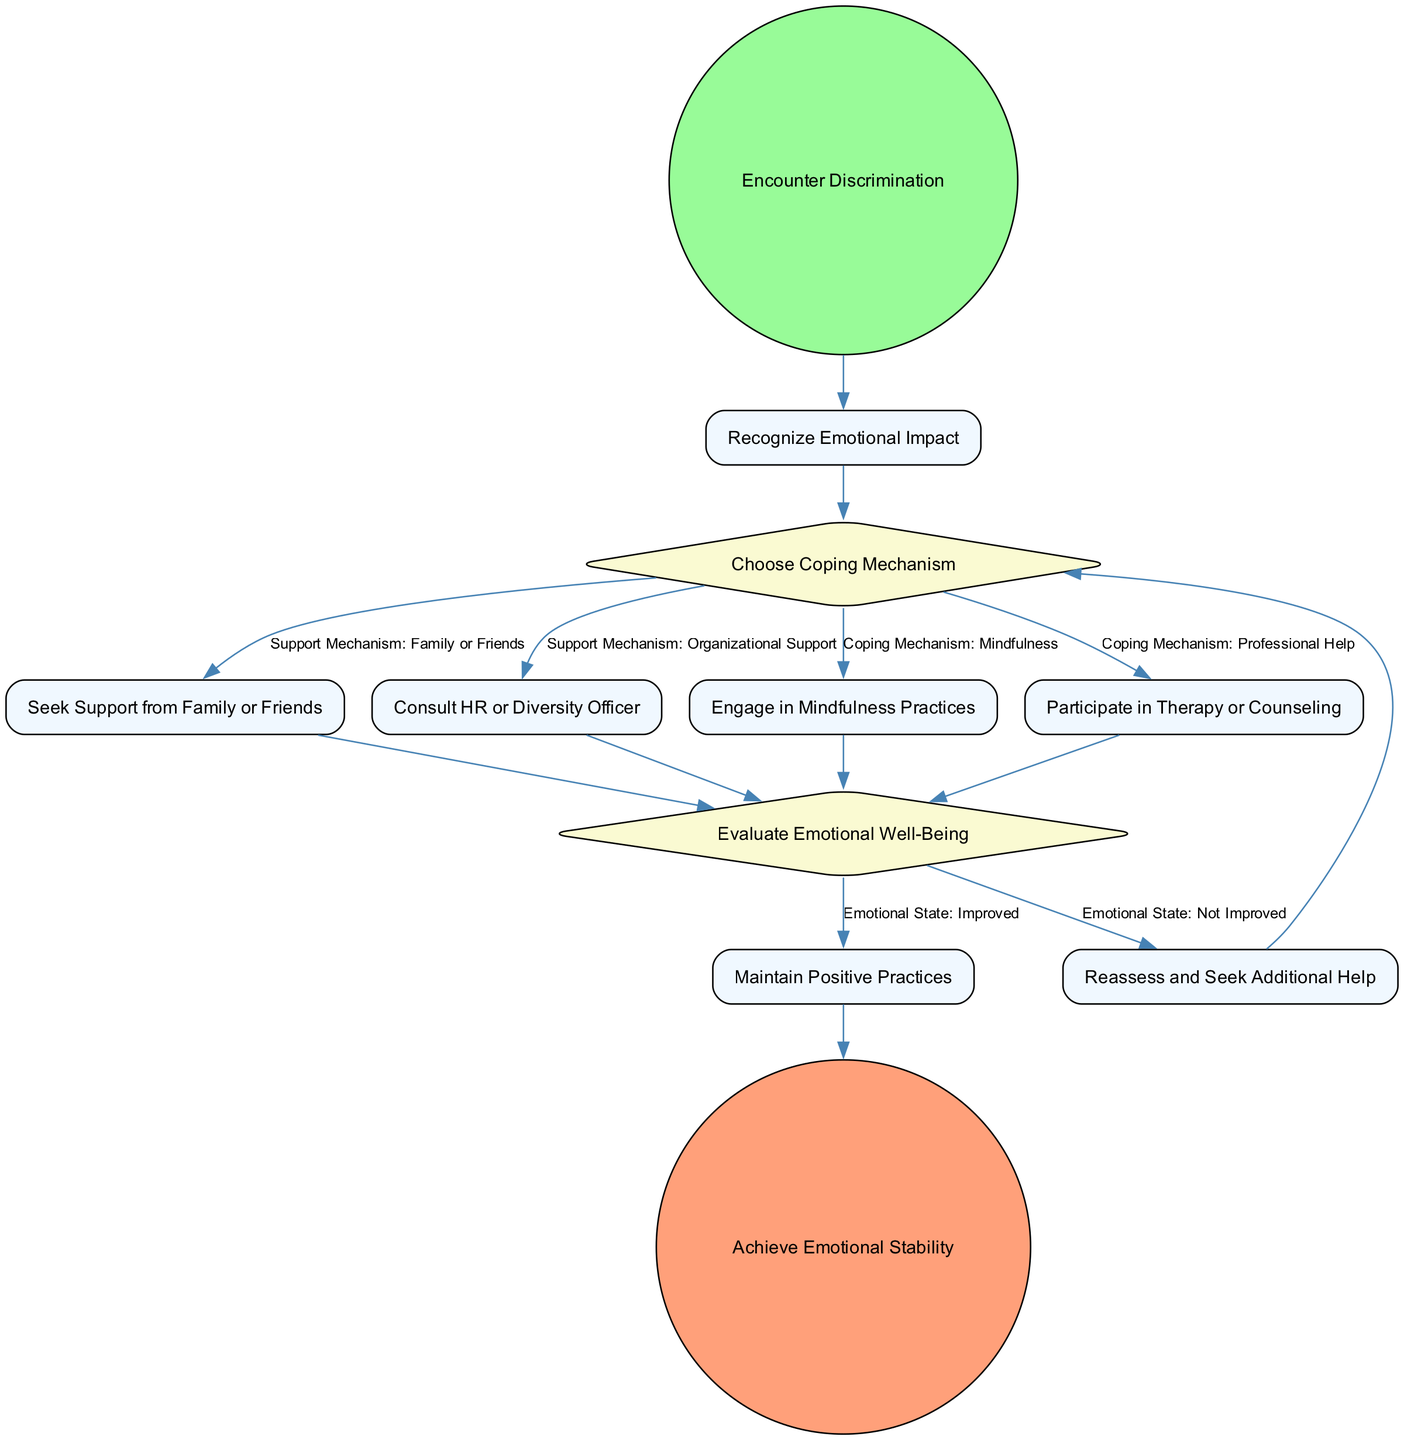What is the starting event in the diagram? The starting event is labeled as "Encounter Discrimination" and serves as the initial point in the activity flow of the diagram.
Answer: Encounter Discrimination What is the final outcome of this process? The final outcome of the process is indicated by the "EndEvent" node, which signifies the completion of activities leading to emotional stability.
Answer: Achieve Emotional Stability How many coping mechanisms are outlined in the diagram? There are four coping mechanisms detailed in the diagram, as specified by the activities that emerge from the "Choose Coping Mechanism" decision node.
Answer: Four What activity follows the "Choose Coping Mechanism" decision if "Mindfulness" is selected? If the "Mindfulness" coping mechanism is chosen, the subsequent activity is "Engage in Mindfulness Practices," which is linked directly to that choice in the activity flow.
Answer: Engage in Mindfulness Practices If the emotional state is "Not Improved," what is the next step according to the diagram? When the emotional state is "Not Improved," the diagram directs to the activity "Reassess and Seek Additional Help," indicating a need for further assistance.
Answer: Reassess and Seek Additional Help What is the condition associated with seeking support from family or friends? The condition specified for seeking support from family or friends is labeled as "Support Mechanism: Family or Friends," showing one of the options for coping.
Answer: Support Mechanism: Family or Friends How many decision nodes are present in the diagram? The diagram includes two decision nodes which guide the flow of activities based on different choices made by the individual facing discrimination.
Answer: Two What action should be taken after evaluating emotional well-being if the state is "Improved"? If the emotional state is evaluated as "Improved," the action to be taken is to "Maintain Positive Practices," as indicated in the flow following that evaluation.
Answer: Maintain Positive Practices 